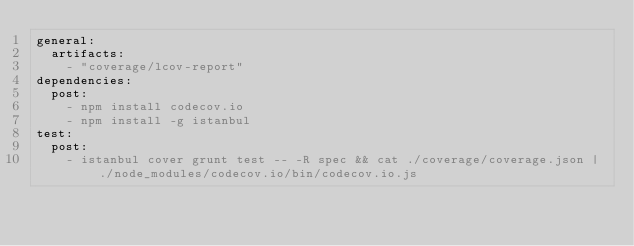<code> <loc_0><loc_0><loc_500><loc_500><_YAML_>general:
  artifacts:
    - "coverage/lcov-report"
dependencies:
  post:
    - npm install codecov.io
    - npm install -g istanbul
test:
  post:
    - istanbul cover grunt test -- -R spec && cat ./coverage/coverage.json | ./node_modules/codecov.io/bin/codecov.io.js</code> 